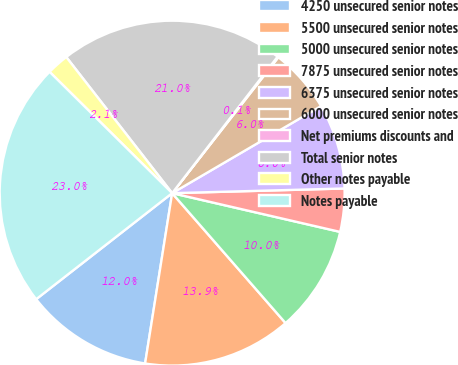Convert chart to OTSL. <chart><loc_0><loc_0><loc_500><loc_500><pie_chart><fcel>4250 unsecured senior notes<fcel>5500 unsecured senior notes<fcel>5000 unsecured senior notes<fcel>7875 unsecured senior notes<fcel>6375 unsecured senior notes<fcel>6000 unsecured senior notes<fcel>Net premiums discounts and<fcel>Total senior notes<fcel>Other notes payable<fcel>Notes payable<nl><fcel>11.95%<fcel>13.93%<fcel>9.97%<fcel>4.04%<fcel>7.99%<fcel>6.02%<fcel>0.09%<fcel>20.99%<fcel>2.06%<fcel>22.96%<nl></chart> 